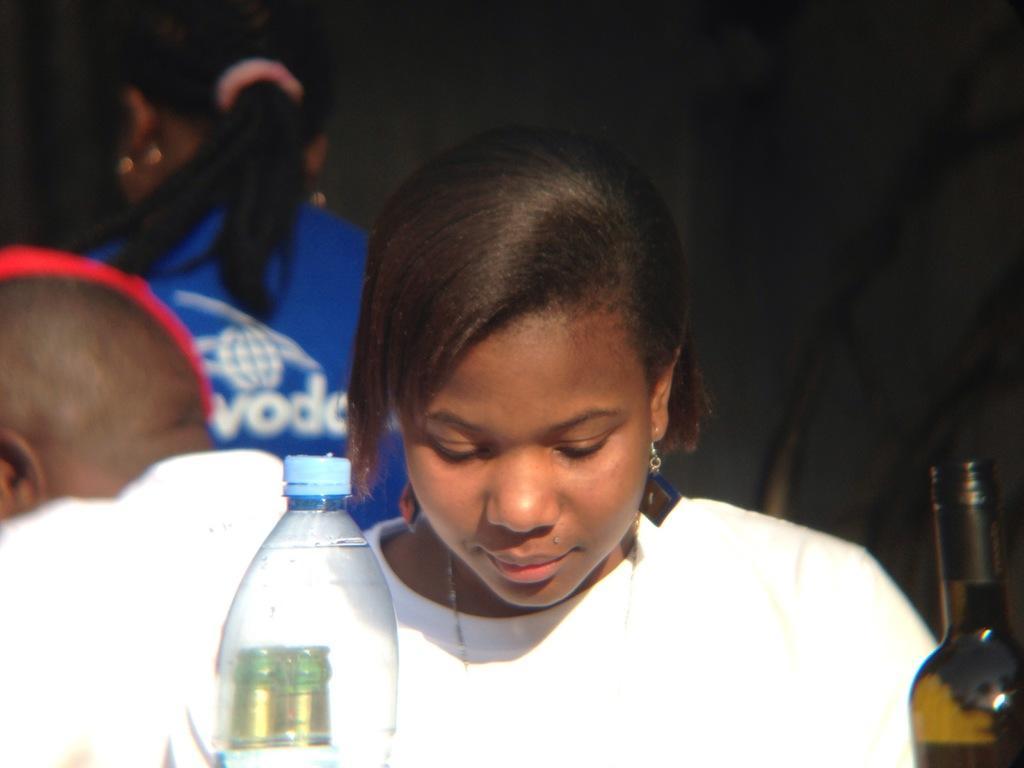Can you describe this image briefly? A woman is sitting at a table with few bottles on it. 